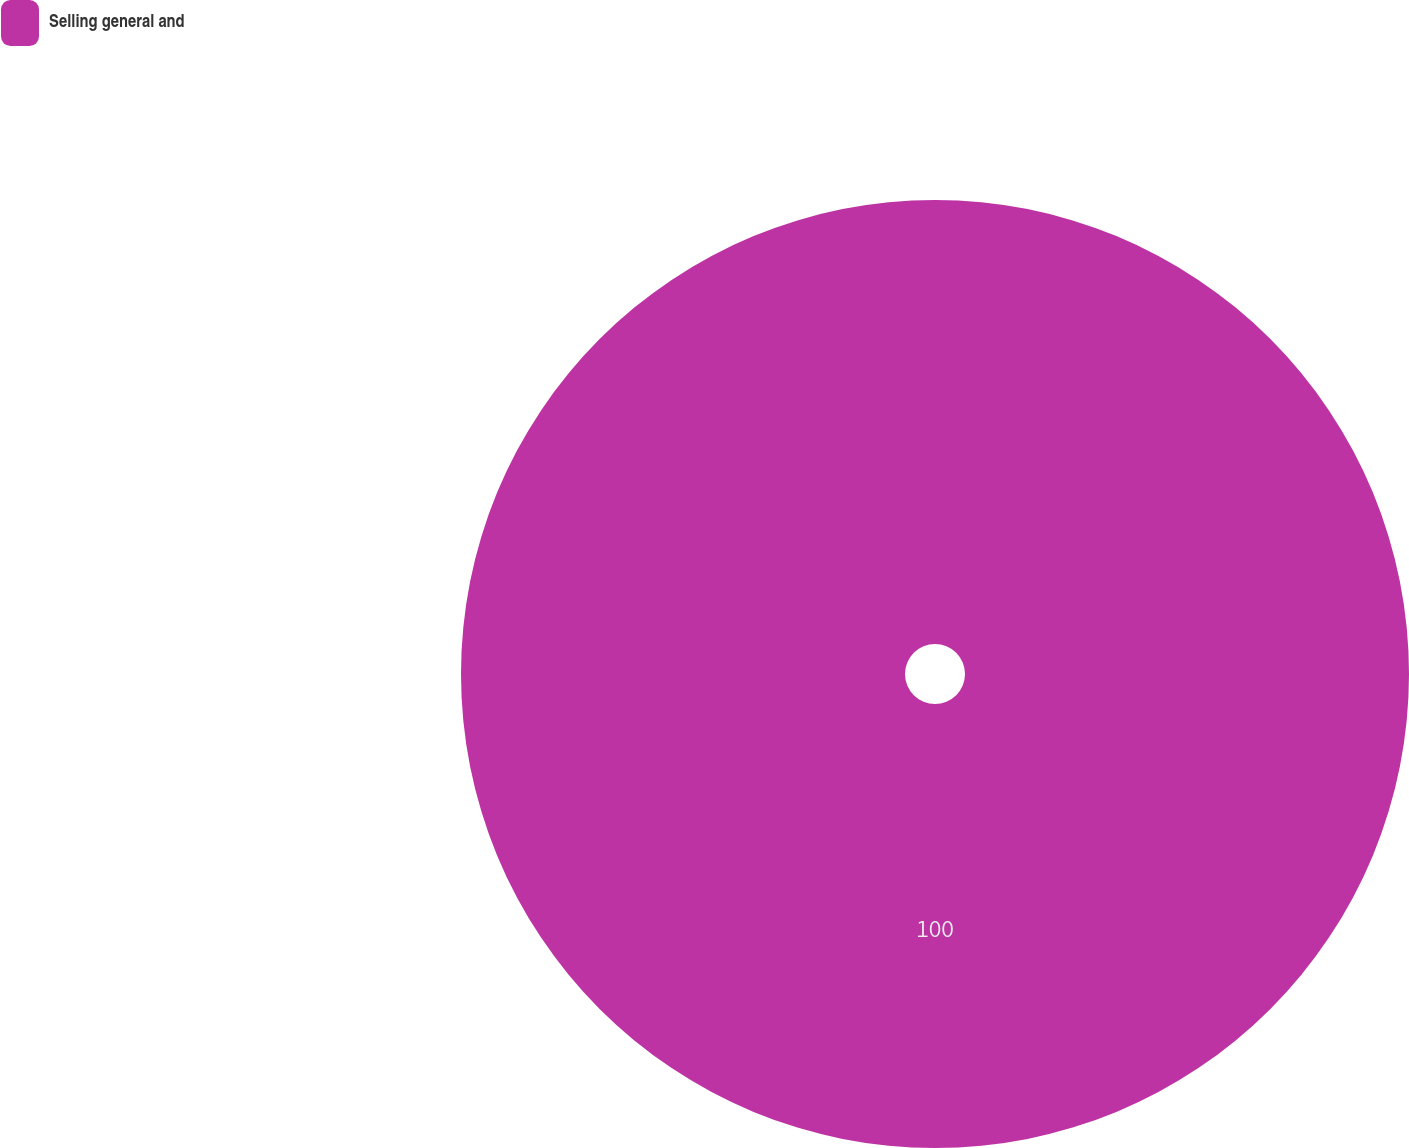Convert chart. <chart><loc_0><loc_0><loc_500><loc_500><pie_chart><fcel>Selling general and<nl><fcel>100.0%<nl></chart> 